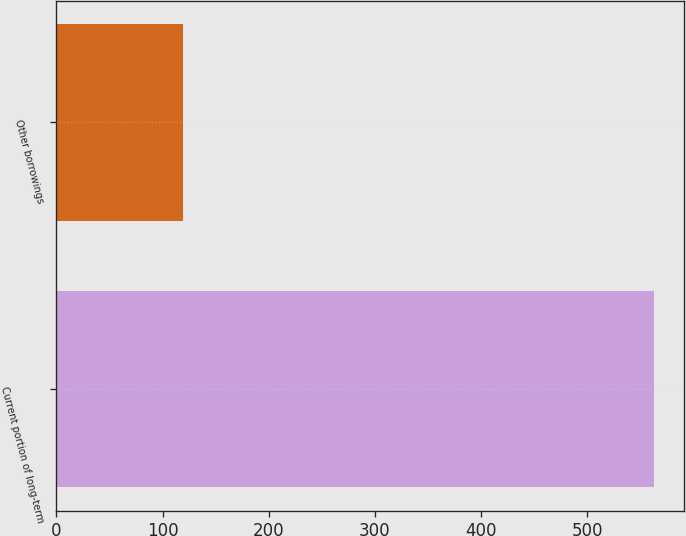<chart> <loc_0><loc_0><loc_500><loc_500><bar_chart><fcel>Current portion of long-term<fcel>Other borrowings<nl><fcel>563<fcel>119<nl></chart> 